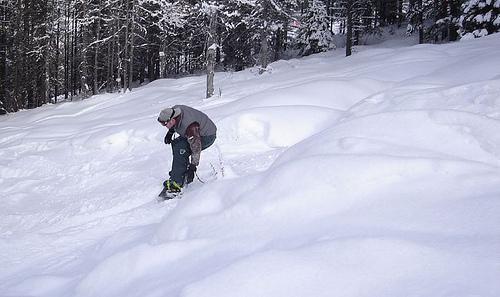How many men are there?
Give a very brief answer. 1. 